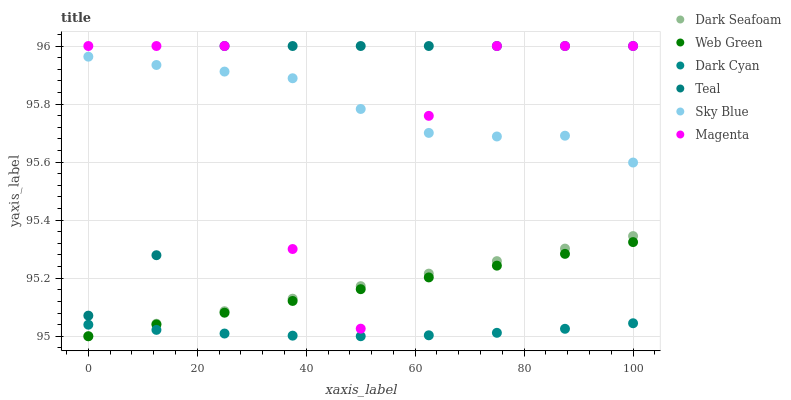Does Dark Cyan have the minimum area under the curve?
Answer yes or no. Yes. Does Teal have the maximum area under the curve?
Answer yes or no. Yes. Does Dark Seafoam have the minimum area under the curve?
Answer yes or no. No. Does Dark Seafoam have the maximum area under the curve?
Answer yes or no. No. Is Web Green the smoothest?
Answer yes or no. Yes. Is Magenta the roughest?
Answer yes or no. Yes. Is Dark Seafoam the smoothest?
Answer yes or no. No. Is Dark Seafoam the roughest?
Answer yes or no. No. Does Web Green have the lowest value?
Answer yes or no. Yes. Does Teal have the lowest value?
Answer yes or no. No. Does Magenta have the highest value?
Answer yes or no. Yes. Does Dark Seafoam have the highest value?
Answer yes or no. No. Is Dark Seafoam less than Teal?
Answer yes or no. Yes. Is Sky Blue greater than Dark Seafoam?
Answer yes or no. Yes. Does Sky Blue intersect Teal?
Answer yes or no. Yes. Is Sky Blue less than Teal?
Answer yes or no. No. Is Sky Blue greater than Teal?
Answer yes or no. No. Does Dark Seafoam intersect Teal?
Answer yes or no. No. 